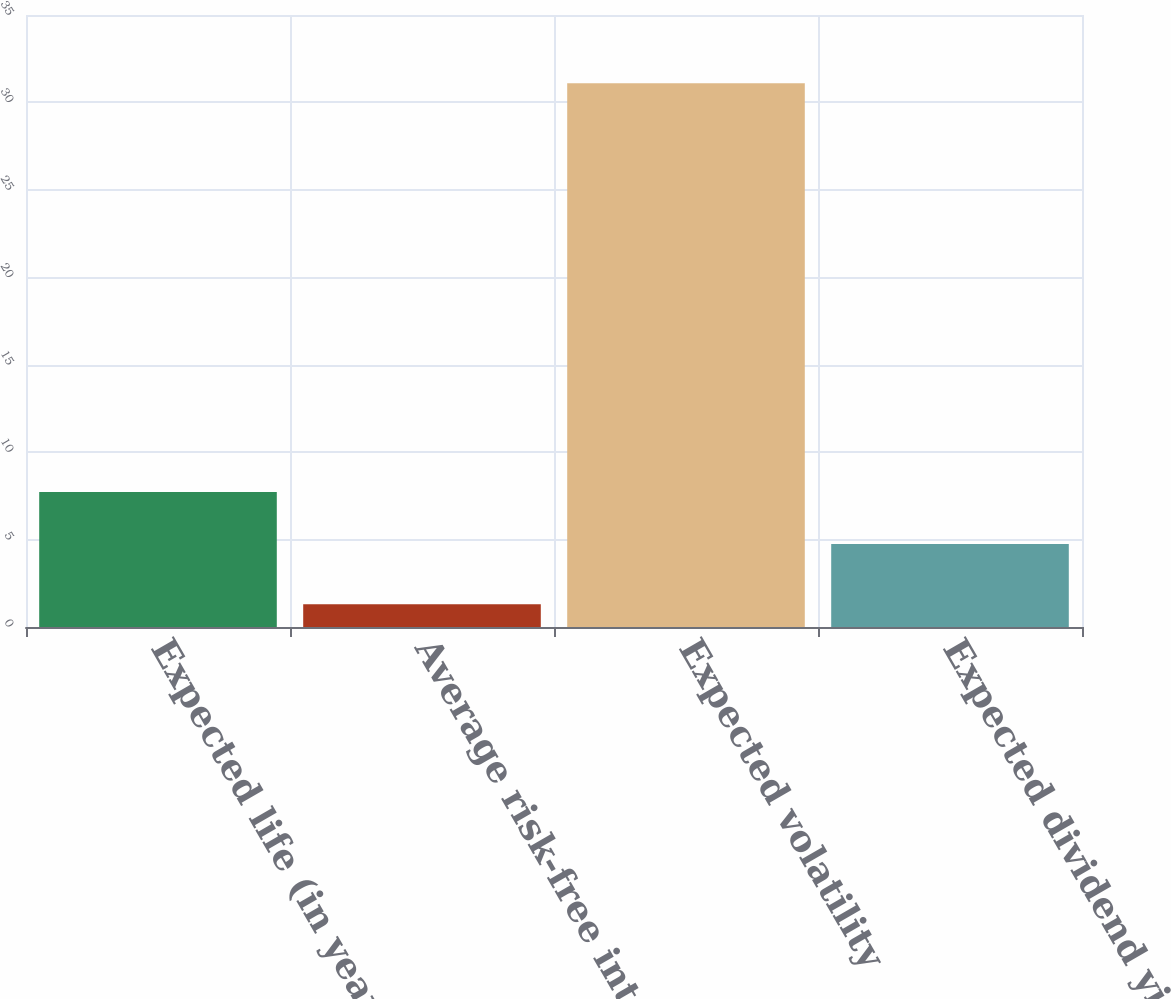<chart> <loc_0><loc_0><loc_500><loc_500><bar_chart><fcel>Expected life (in years)<fcel>Average risk-free interest<fcel>Expected volatility<fcel>Expected dividend yield<nl><fcel>7.72<fcel>1.3<fcel>31.1<fcel>4.74<nl></chart> 